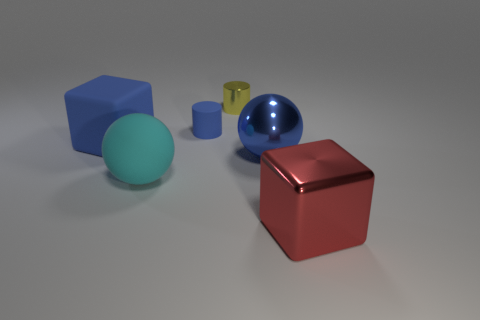Are there the same number of large red cubes behind the yellow cylinder and large blue shiny objects that are in front of the big shiny sphere? Upon closer inspection of the image, it appears that there is only one large red cube and it is positioned in front of the yellow cylinder, not behind it. Additionally, there is only one large blue shiny object, which is a sphere. Since there are no large red cubes behind the cylinder and only one large blue object in front of the shiny sphere, the comparison isn't valid—and as such, the answer to your question is that the premise is incorrect, thus the counts cannot be the same. 